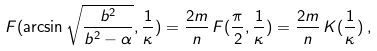Convert formula to latex. <formula><loc_0><loc_0><loc_500><loc_500>F ( \arcsin \sqrt { \frac { b ^ { 2 } } { b ^ { 2 } - \alpha } } , \frac { 1 } { \kappa } ) = \frac { 2 m } { n } \, F ( \frac { \pi } { 2 } , \frac { 1 } { \kappa } ) = \frac { 2 m } { n } \, K ( \frac { 1 } { \kappa } ) \, ,</formula> 